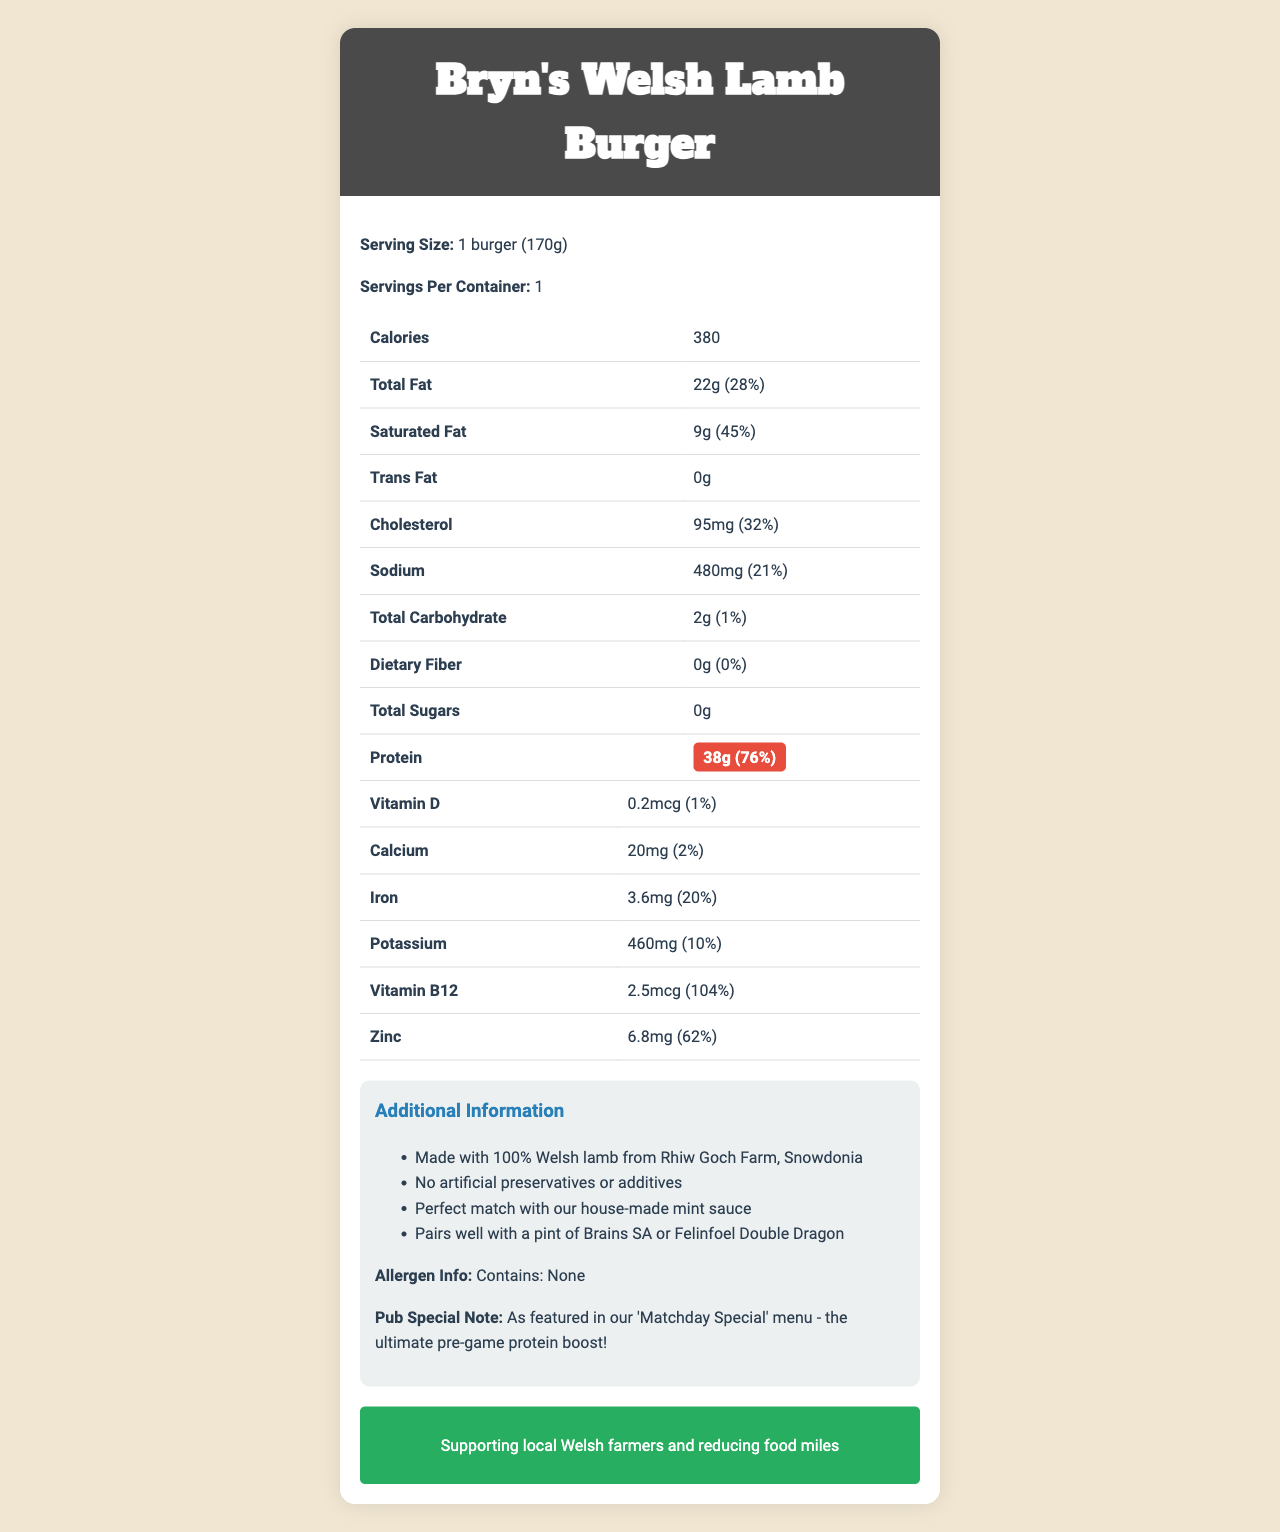what is the serving size for Bryn's Welsh Lamb Burger? The serving size is specified as "1 burger (170g)" in the document.
Answer: 1 burger (170g) what is the protein content per serving? The document highlights that the protein content per serving is 38g.
Answer: 38g how much cholesterol does one serving contain? The document lists cholesterol content as 95mg per serving.
Answer: 95mg how many calories are there in one Bryn's Welsh Lamb Burger? The document indicates there are 380 calories in one serving of the lamb burger.
Answer: 380 which vitamin has the highest daily value percentage? The document shows that Vitamin B12 has a daily value percentage of 104%, which is the highest.
Answer: Vitamin B12 what is the suggested pairing beverage according to the document? A. Brains SA B. Felinfoel Double Dragon C. Both A and B The document suggests that the lamb burger pairs well with both Brains SA and Felinfoel Double Dragon.
Answer: C. Both A and B how much saturated fat does the burger contain? A. 22g B. 9g C. 0g D. 6.8mg The document specifies that the saturated fat content of the burger is 9g.
Answer: B. 9g is the Bryn's Welsh Lamb Burger allergen-free? According to the allergen information section, the burger contains no allergens.
Answer: Yes summarize the main idea of the document. The document provides details about the nutritional content of Bryn's Welsh Lamb Burger, highlighting its protein content and essential nutrients. It also includes additional notes on what pairs well with the burger, allergen information, and sustainability efforts.
Answer: Description of Bryn's Welsh Lamb Burger's nutrition facts and additional information. can we determine the price of the Bryn's Welsh Lamb Burger from this document? The document does not provide any details related to the price of the lamb burger.
Answer: Not enough information 